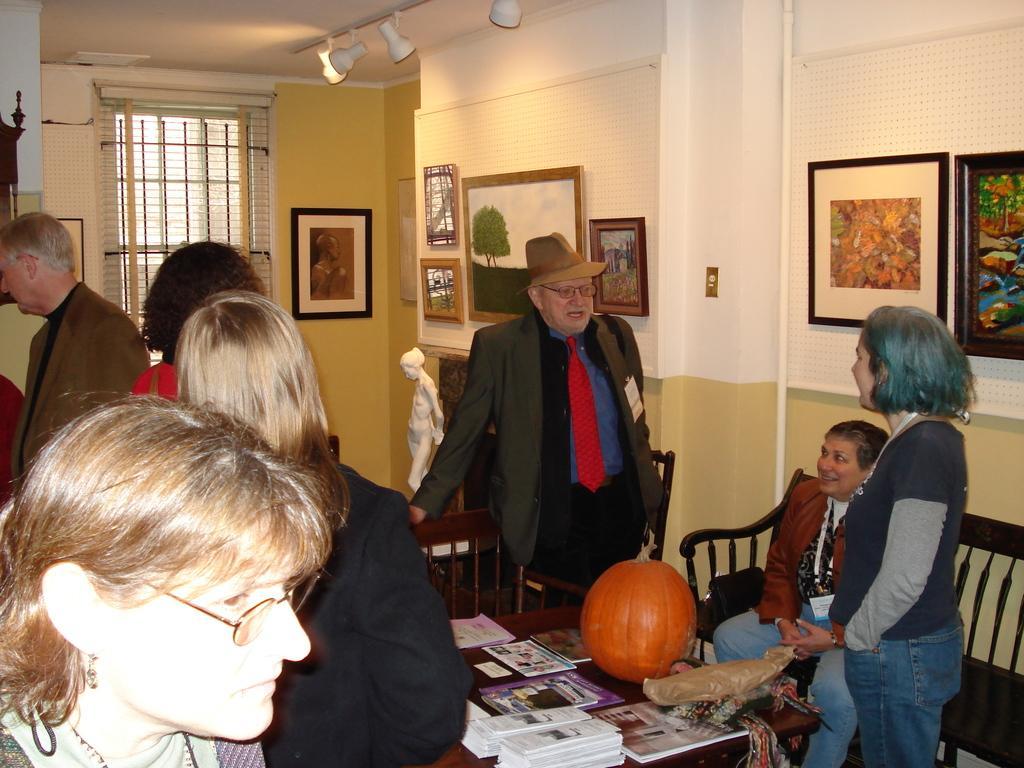In one or two sentences, can you explain what this image depicts? In this image we can see many people. There is a table. On the table there are books, pumpkin and some other items. There is a person wearing hat and specs. Also we can see a bench and chair. In the back there is a statue. And we can see walls with photo frames. On the ceiling there are lights. And there are photo frames on the wall. In the back there is a window. 